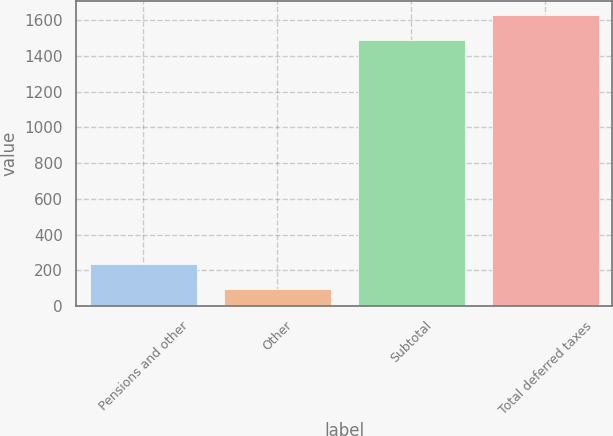Convert chart. <chart><loc_0><loc_0><loc_500><loc_500><bar_chart><fcel>Pensions and other<fcel>Other<fcel>Subtotal<fcel>Total deferred taxes<nl><fcel>235.07<fcel>95.9<fcel>1487.6<fcel>1626.77<nl></chart> 